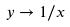<formula> <loc_0><loc_0><loc_500><loc_500>y \rightarrow 1 / x</formula> 